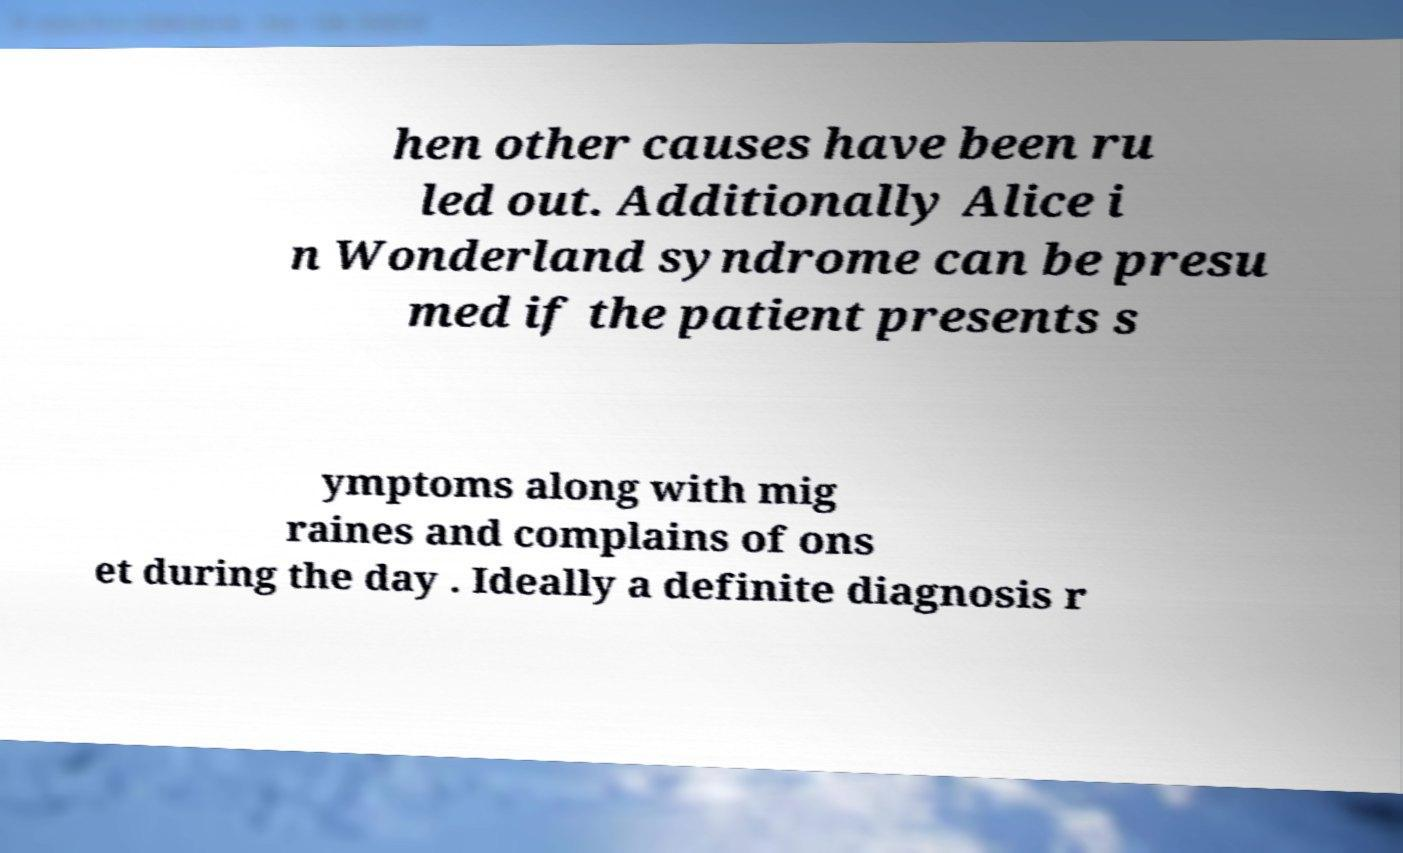Could you assist in decoding the text presented in this image and type it out clearly? hen other causes have been ru led out. Additionally Alice i n Wonderland syndrome can be presu med if the patient presents s ymptoms along with mig raines and complains of ons et during the day . Ideally a definite diagnosis r 